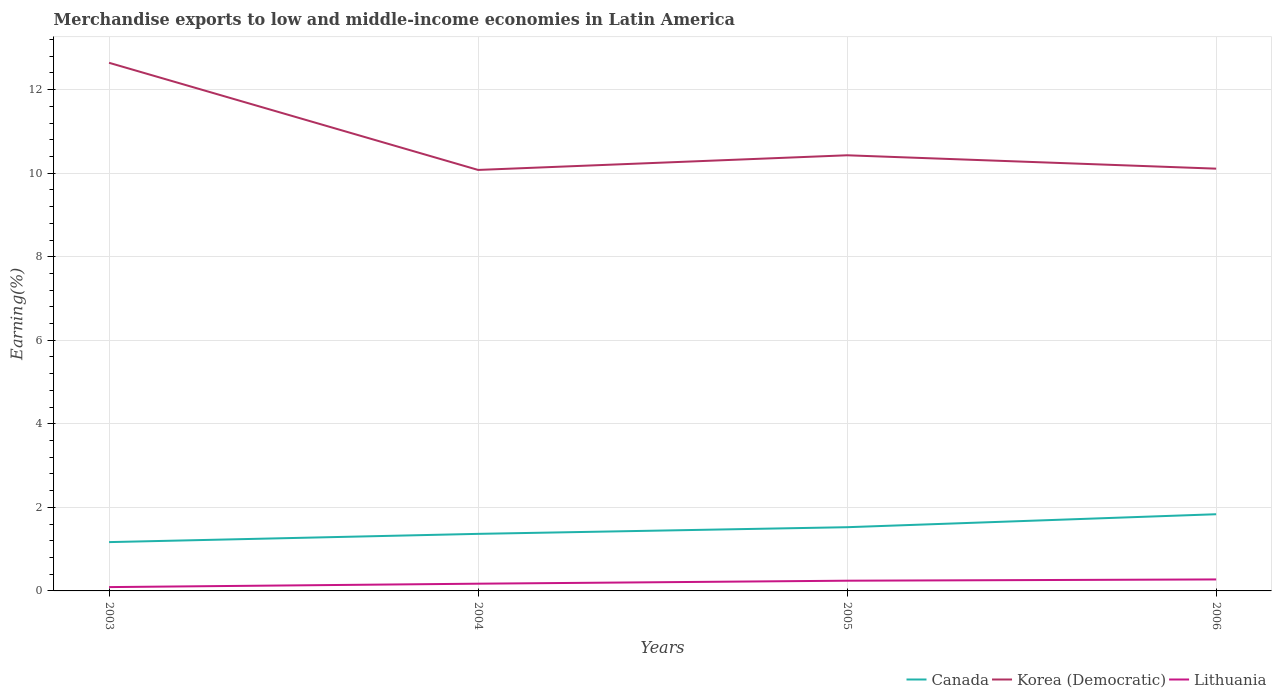How many different coloured lines are there?
Offer a terse response. 3. Does the line corresponding to Korea (Democratic) intersect with the line corresponding to Lithuania?
Offer a terse response. No. Is the number of lines equal to the number of legend labels?
Your answer should be very brief. Yes. Across all years, what is the maximum percentage of amount earned from merchandise exports in Lithuania?
Your answer should be very brief. 0.09. In which year was the percentage of amount earned from merchandise exports in Korea (Democratic) maximum?
Ensure brevity in your answer.  2004. What is the total percentage of amount earned from merchandise exports in Canada in the graph?
Your answer should be very brief. -0.67. What is the difference between the highest and the second highest percentage of amount earned from merchandise exports in Lithuania?
Your answer should be compact. 0.18. What is the difference between the highest and the lowest percentage of amount earned from merchandise exports in Canada?
Your answer should be very brief. 2. Is the percentage of amount earned from merchandise exports in Canada strictly greater than the percentage of amount earned from merchandise exports in Lithuania over the years?
Provide a succinct answer. No. How many lines are there?
Your answer should be very brief. 3. How many years are there in the graph?
Your answer should be compact. 4. Does the graph contain grids?
Offer a terse response. Yes. Where does the legend appear in the graph?
Provide a short and direct response. Bottom right. How many legend labels are there?
Provide a short and direct response. 3. What is the title of the graph?
Offer a terse response. Merchandise exports to low and middle-income economies in Latin America. Does "Other small states" appear as one of the legend labels in the graph?
Give a very brief answer. No. What is the label or title of the Y-axis?
Give a very brief answer. Earning(%). What is the Earning(%) of Canada in 2003?
Provide a succinct answer. 1.17. What is the Earning(%) in Korea (Democratic) in 2003?
Offer a terse response. 12.64. What is the Earning(%) in Lithuania in 2003?
Offer a very short reply. 0.09. What is the Earning(%) of Canada in 2004?
Make the answer very short. 1.37. What is the Earning(%) in Korea (Democratic) in 2004?
Keep it short and to the point. 10.08. What is the Earning(%) in Lithuania in 2004?
Ensure brevity in your answer.  0.17. What is the Earning(%) in Canada in 2005?
Make the answer very short. 1.53. What is the Earning(%) of Korea (Democratic) in 2005?
Provide a succinct answer. 10.43. What is the Earning(%) in Lithuania in 2005?
Your response must be concise. 0.24. What is the Earning(%) in Canada in 2006?
Provide a succinct answer. 1.84. What is the Earning(%) in Korea (Democratic) in 2006?
Provide a succinct answer. 10.11. What is the Earning(%) in Lithuania in 2006?
Keep it short and to the point. 0.27. Across all years, what is the maximum Earning(%) in Canada?
Provide a short and direct response. 1.84. Across all years, what is the maximum Earning(%) in Korea (Democratic)?
Provide a short and direct response. 12.64. Across all years, what is the maximum Earning(%) of Lithuania?
Your answer should be very brief. 0.27. Across all years, what is the minimum Earning(%) in Canada?
Provide a succinct answer. 1.17. Across all years, what is the minimum Earning(%) in Korea (Democratic)?
Your answer should be very brief. 10.08. Across all years, what is the minimum Earning(%) of Lithuania?
Offer a terse response. 0.09. What is the total Earning(%) of Canada in the graph?
Offer a very short reply. 5.9. What is the total Earning(%) in Korea (Democratic) in the graph?
Provide a short and direct response. 43.26. What is the total Earning(%) of Lithuania in the graph?
Provide a succinct answer. 0.78. What is the difference between the Earning(%) in Canada in 2003 and that in 2004?
Your response must be concise. -0.2. What is the difference between the Earning(%) in Korea (Democratic) in 2003 and that in 2004?
Your answer should be compact. 2.56. What is the difference between the Earning(%) of Lithuania in 2003 and that in 2004?
Offer a terse response. -0.08. What is the difference between the Earning(%) of Canada in 2003 and that in 2005?
Provide a short and direct response. -0.36. What is the difference between the Earning(%) of Korea (Democratic) in 2003 and that in 2005?
Keep it short and to the point. 2.21. What is the difference between the Earning(%) of Lithuania in 2003 and that in 2005?
Offer a very short reply. -0.15. What is the difference between the Earning(%) of Canada in 2003 and that in 2006?
Your response must be concise. -0.67. What is the difference between the Earning(%) of Korea (Democratic) in 2003 and that in 2006?
Offer a very short reply. 2.53. What is the difference between the Earning(%) in Lithuania in 2003 and that in 2006?
Your answer should be compact. -0.18. What is the difference between the Earning(%) of Canada in 2004 and that in 2005?
Your response must be concise. -0.16. What is the difference between the Earning(%) in Korea (Democratic) in 2004 and that in 2005?
Your response must be concise. -0.35. What is the difference between the Earning(%) in Lithuania in 2004 and that in 2005?
Offer a terse response. -0.07. What is the difference between the Earning(%) of Canada in 2004 and that in 2006?
Keep it short and to the point. -0.47. What is the difference between the Earning(%) of Korea (Democratic) in 2004 and that in 2006?
Offer a terse response. -0.03. What is the difference between the Earning(%) in Lithuania in 2004 and that in 2006?
Ensure brevity in your answer.  -0.1. What is the difference between the Earning(%) in Canada in 2005 and that in 2006?
Your response must be concise. -0.31. What is the difference between the Earning(%) in Korea (Democratic) in 2005 and that in 2006?
Offer a very short reply. 0.32. What is the difference between the Earning(%) of Lithuania in 2005 and that in 2006?
Your answer should be compact. -0.03. What is the difference between the Earning(%) in Canada in 2003 and the Earning(%) in Korea (Democratic) in 2004?
Give a very brief answer. -8.91. What is the difference between the Earning(%) in Canada in 2003 and the Earning(%) in Lithuania in 2004?
Your response must be concise. 1. What is the difference between the Earning(%) of Korea (Democratic) in 2003 and the Earning(%) of Lithuania in 2004?
Provide a succinct answer. 12.47. What is the difference between the Earning(%) of Canada in 2003 and the Earning(%) of Korea (Democratic) in 2005?
Your answer should be very brief. -9.26. What is the difference between the Earning(%) in Canada in 2003 and the Earning(%) in Lithuania in 2005?
Offer a very short reply. 0.92. What is the difference between the Earning(%) of Korea (Democratic) in 2003 and the Earning(%) of Lithuania in 2005?
Make the answer very short. 12.4. What is the difference between the Earning(%) of Canada in 2003 and the Earning(%) of Korea (Democratic) in 2006?
Your answer should be very brief. -8.94. What is the difference between the Earning(%) in Canada in 2003 and the Earning(%) in Lithuania in 2006?
Keep it short and to the point. 0.89. What is the difference between the Earning(%) in Korea (Democratic) in 2003 and the Earning(%) in Lithuania in 2006?
Provide a succinct answer. 12.37. What is the difference between the Earning(%) in Canada in 2004 and the Earning(%) in Korea (Democratic) in 2005?
Ensure brevity in your answer.  -9.06. What is the difference between the Earning(%) in Canada in 2004 and the Earning(%) in Lithuania in 2005?
Your answer should be very brief. 1.12. What is the difference between the Earning(%) of Korea (Democratic) in 2004 and the Earning(%) of Lithuania in 2005?
Your answer should be compact. 9.83. What is the difference between the Earning(%) in Canada in 2004 and the Earning(%) in Korea (Democratic) in 2006?
Your answer should be compact. -8.74. What is the difference between the Earning(%) of Canada in 2004 and the Earning(%) of Lithuania in 2006?
Provide a succinct answer. 1.09. What is the difference between the Earning(%) in Korea (Democratic) in 2004 and the Earning(%) in Lithuania in 2006?
Provide a succinct answer. 9.8. What is the difference between the Earning(%) in Canada in 2005 and the Earning(%) in Korea (Democratic) in 2006?
Give a very brief answer. -8.58. What is the difference between the Earning(%) in Canada in 2005 and the Earning(%) in Lithuania in 2006?
Ensure brevity in your answer.  1.25. What is the difference between the Earning(%) of Korea (Democratic) in 2005 and the Earning(%) of Lithuania in 2006?
Offer a very short reply. 10.15. What is the average Earning(%) of Canada per year?
Ensure brevity in your answer.  1.47. What is the average Earning(%) in Korea (Democratic) per year?
Provide a succinct answer. 10.81. What is the average Earning(%) in Lithuania per year?
Offer a terse response. 0.2. In the year 2003, what is the difference between the Earning(%) of Canada and Earning(%) of Korea (Democratic)?
Your response must be concise. -11.47. In the year 2003, what is the difference between the Earning(%) in Canada and Earning(%) in Lithuania?
Keep it short and to the point. 1.08. In the year 2003, what is the difference between the Earning(%) of Korea (Democratic) and Earning(%) of Lithuania?
Make the answer very short. 12.55. In the year 2004, what is the difference between the Earning(%) of Canada and Earning(%) of Korea (Democratic)?
Give a very brief answer. -8.71. In the year 2004, what is the difference between the Earning(%) in Canada and Earning(%) in Lithuania?
Your answer should be very brief. 1.19. In the year 2004, what is the difference between the Earning(%) of Korea (Democratic) and Earning(%) of Lithuania?
Offer a terse response. 9.9. In the year 2005, what is the difference between the Earning(%) in Canada and Earning(%) in Korea (Democratic)?
Keep it short and to the point. -8.9. In the year 2005, what is the difference between the Earning(%) of Canada and Earning(%) of Lithuania?
Your answer should be very brief. 1.28. In the year 2005, what is the difference between the Earning(%) of Korea (Democratic) and Earning(%) of Lithuania?
Your response must be concise. 10.18. In the year 2006, what is the difference between the Earning(%) of Canada and Earning(%) of Korea (Democratic)?
Your response must be concise. -8.27. In the year 2006, what is the difference between the Earning(%) in Canada and Earning(%) in Lithuania?
Your answer should be compact. 1.56. In the year 2006, what is the difference between the Earning(%) in Korea (Democratic) and Earning(%) in Lithuania?
Keep it short and to the point. 9.83. What is the ratio of the Earning(%) in Canada in 2003 to that in 2004?
Offer a very short reply. 0.86. What is the ratio of the Earning(%) in Korea (Democratic) in 2003 to that in 2004?
Offer a very short reply. 1.25. What is the ratio of the Earning(%) in Lithuania in 2003 to that in 2004?
Give a very brief answer. 0.53. What is the ratio of the Earning(%) in Canada in 2003 to that in 2005?
Your answer should be compact. 0.77. What is the ratio of the Earning(%) in Korea (Democratic) in 2003 to that in 2005?
Offer a terse response. 1.21. What is the ratio of the Earning(%) in Lithuania in 2003 to that in 2005?
Ensure brevity in your answer.  0.37. What is the ratio of the Earning(%) of Canada in 2003 to that in 2006?
Ensure brevity in your answer.  0.64. What is the ratio of the Earning(%) of Korea (Democratic) in 2003 to that in 2006?
Offer a terse response. 1.25. What is the ratio of the Earning(%) of Lithuania in 2003 to that in 2006?
Your answer should be compact. 0.33. What is the ratio of the Earning(%) in Canada in 2004 to that in 2005?
Your answer should be compact. 0.9. What is the ratio of the Earning(%) of Korea (Democratic) in 2004 to that in 2005?
Provide a succinct answer. 0.97. What is the ratio of the Earning(%) in Lithuania in 2004 to that in 2005?
Ensure brevity in your answer.  0.71. What is the ratio of the Earning(%) of Canada in 2004 to that in 2006?
Offer a very short reply. 0.74. What is the ratio of the Earning(%) in Lithuania in 2004 to that in 2006?
Keep it short and to the point. 0.63. What is the ratio of the Earning(%) in Canada in 2005 to that in 2006?
Your response must be concise. 0.83. What is the ratio of the Earning(%) of Korea (Democratic) in 2005 to that in 2006?
Ensure brevity in your answer.  1.03. What is the ratio of the Earning(%) in Lithuania in 2005 to that in 2006?
Your answer should be very brief. 0.89. What is the difference between the highest and the second highest Earning(%) in Canada?
Ensure brevity in your answer.  0.31. What is the difference between the highest and the second highest Earning(%) in Korea (Democratic)?
Your response must be concise. 2.21. What is the difference between the highest and the second highest Earning(%) in Lithuania?
Provide a short and direct response. 0.03. What is the difference between the highest and the lowest Earning(%) of Canada?
Ensure brevity in your answer.  0.67. What is the difference between the highest and the lowest Earning(%) of Korea (Democratic)?
Your answer should be compact. 2.56. What is the difference between the highest and the lowest Earning(%) of Lithuania?
Give a very brief answer. 0.18. 